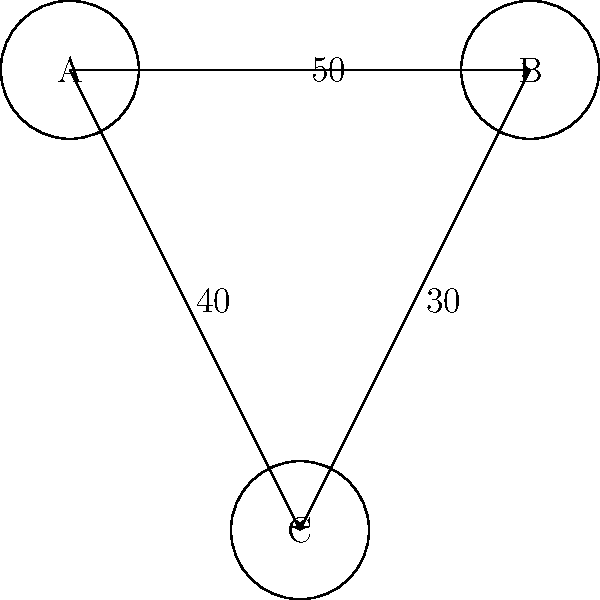In the network flow model representing immigration patterns between countries A, B, and C, what is the maximum flow of immigrants from country A to country C, considering both direct and indirect paths? To solve this problem, we need to analyze the network flow model and apply the concept of maximum flow. Let's break it down step-by-step:

1. Identify the paths from A to C:
   - Direct path: A → C (capacity: 40)
   - Indirect path: A → B → C (capacities: 50 and 30)

2. Calculate the flow through the indirect path:
   - The flow is limited by the minimum capacity in the path
   - Min(50, 30) = 30

3. Calculate the total maximum flow:
   - Direct path flow: 40
   - Indirect path flow: 30
   - Total flow: 40 + 30 = 70

4. Check if this flow satisfies capacity constraints:
   - A → B: 30 ≤ 50 (satisfied)
   - B → C: 30 ≤ 30 (satisfied)
   - A → C: 40 ≤ 40 (satisfied)

5. Verify that no alternative flow distribution yields a higher total flow.

Therefore, the maximum flow of immigrants from country A to country C is 70.
Answer: 70 immigrants 